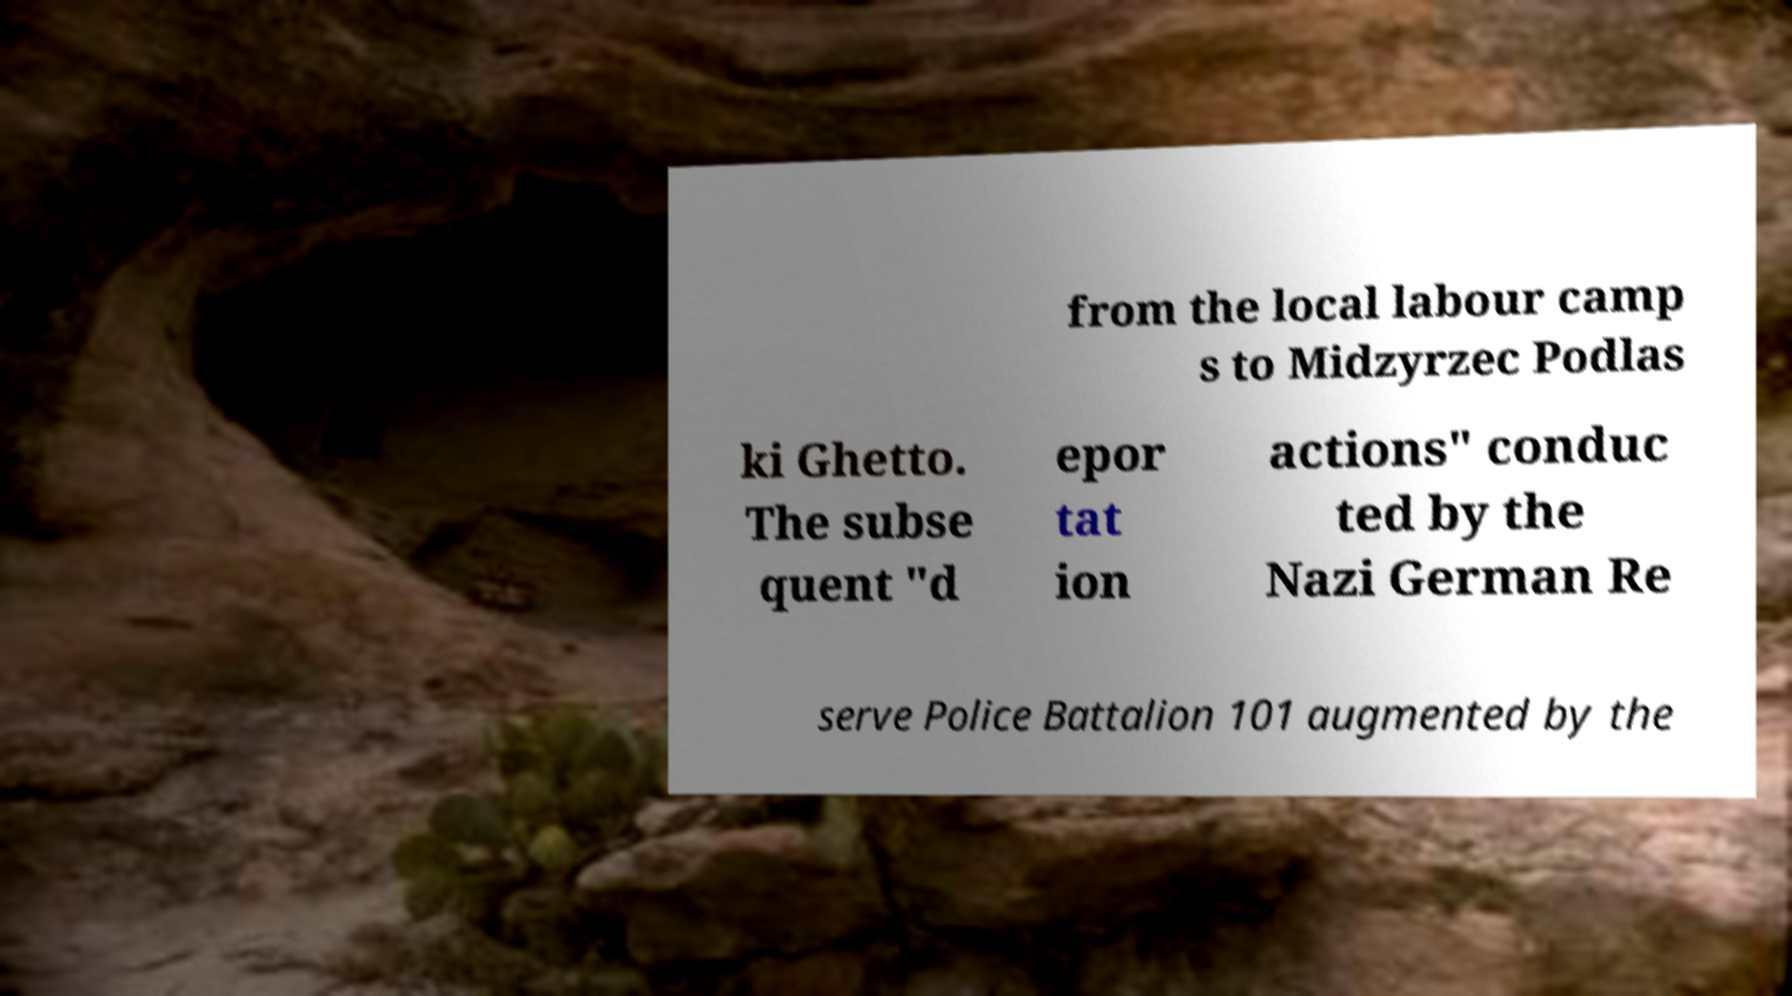For documentation purposes, I need the text within this image transcribed. Could you provide that? from the local labour camp s to Midzyrzec Podlas ki Ghetto. The subse quent "d epor tat ion actions" conduc ted by the Nazi German Re serve Police Battalion 101 augmented by the 